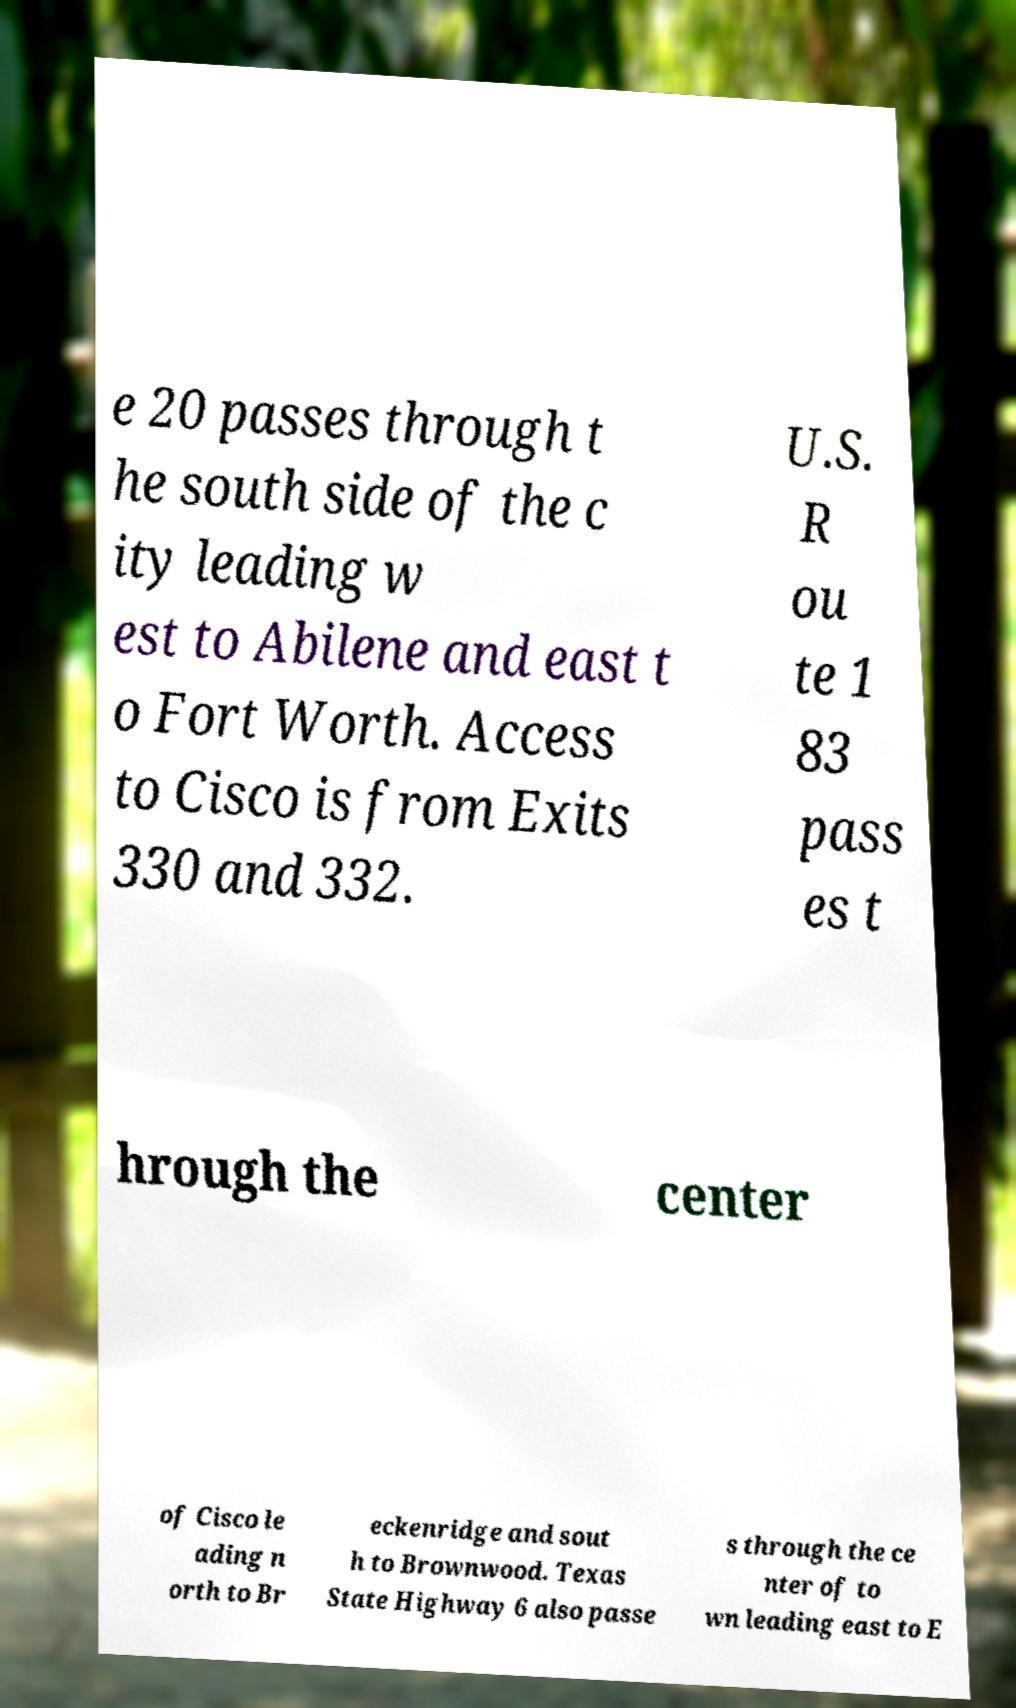Could you extract and type out the text from this image? e 20 passes through t he south side of the c ity leading w est to Abilene and east t o Fort Worth. Access to Cisco is from Exits 330 and 332. U.S. R ou te 1 83 pass es t hrough the center of Cisco le ading n orth to Br eckenridge and sout h to Brownwood. Texas State Highway 6 also passe s through the ce nter of to wn leading east to E 